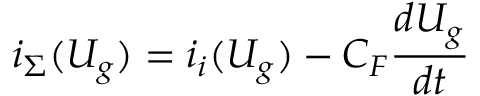<formula> <loc_0><loc_0><loc_500><loc_500>i _ { \Sigma } ( U _ { g } ) = i _ { i } ( U _ { g } ) - C _ { F } { \frac { d U _ { g } } { d t } }</formula> 